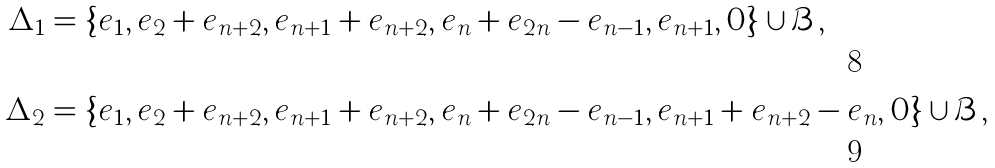<formula> <loc_0><loc_0><loc_500><loc_500>\Delta _ { 1 } & = \{ e _ { 1 } , e _ { 2 } + e _ { n + 2 } , e _ { n + 1 } + e _ { n + 2 } , e _ { n } + e _ { 2 n } - e _ { n - 1 } , e _ { n + 1 } , 0 \} \cup \mathcal { B } , \\ \Delta _ { 2 } & = \{ e _ { 1 } , e _ { 2 } + e _ { n + 2 } , e _ { n + 1 } + e _ { n + 2 } , e _ { n } + e _ { 2 n } - e _ { n - 1 } , e _ { n + 1 } + e _ { n + 2 } - e _ { n } , 0 \} \cup \mathcal { B } ,</formula> 